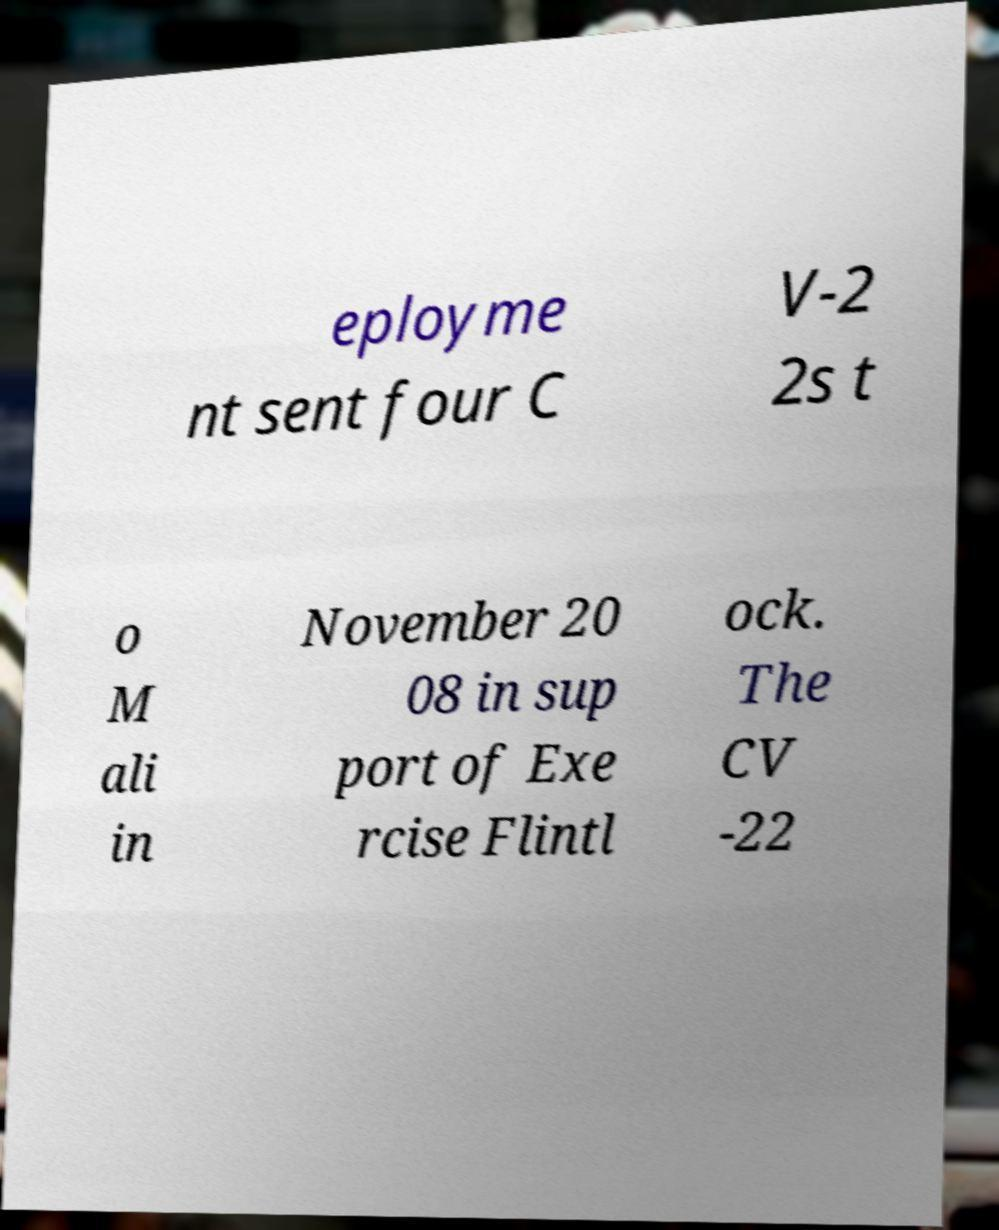For documentation purposes, I need the text within this image transcribed. Could you provide that? eployme nt sent four C V-2 2s t o M ali in November 20 08 in sup port of Exe rcise Flintl ock. The CV -22 